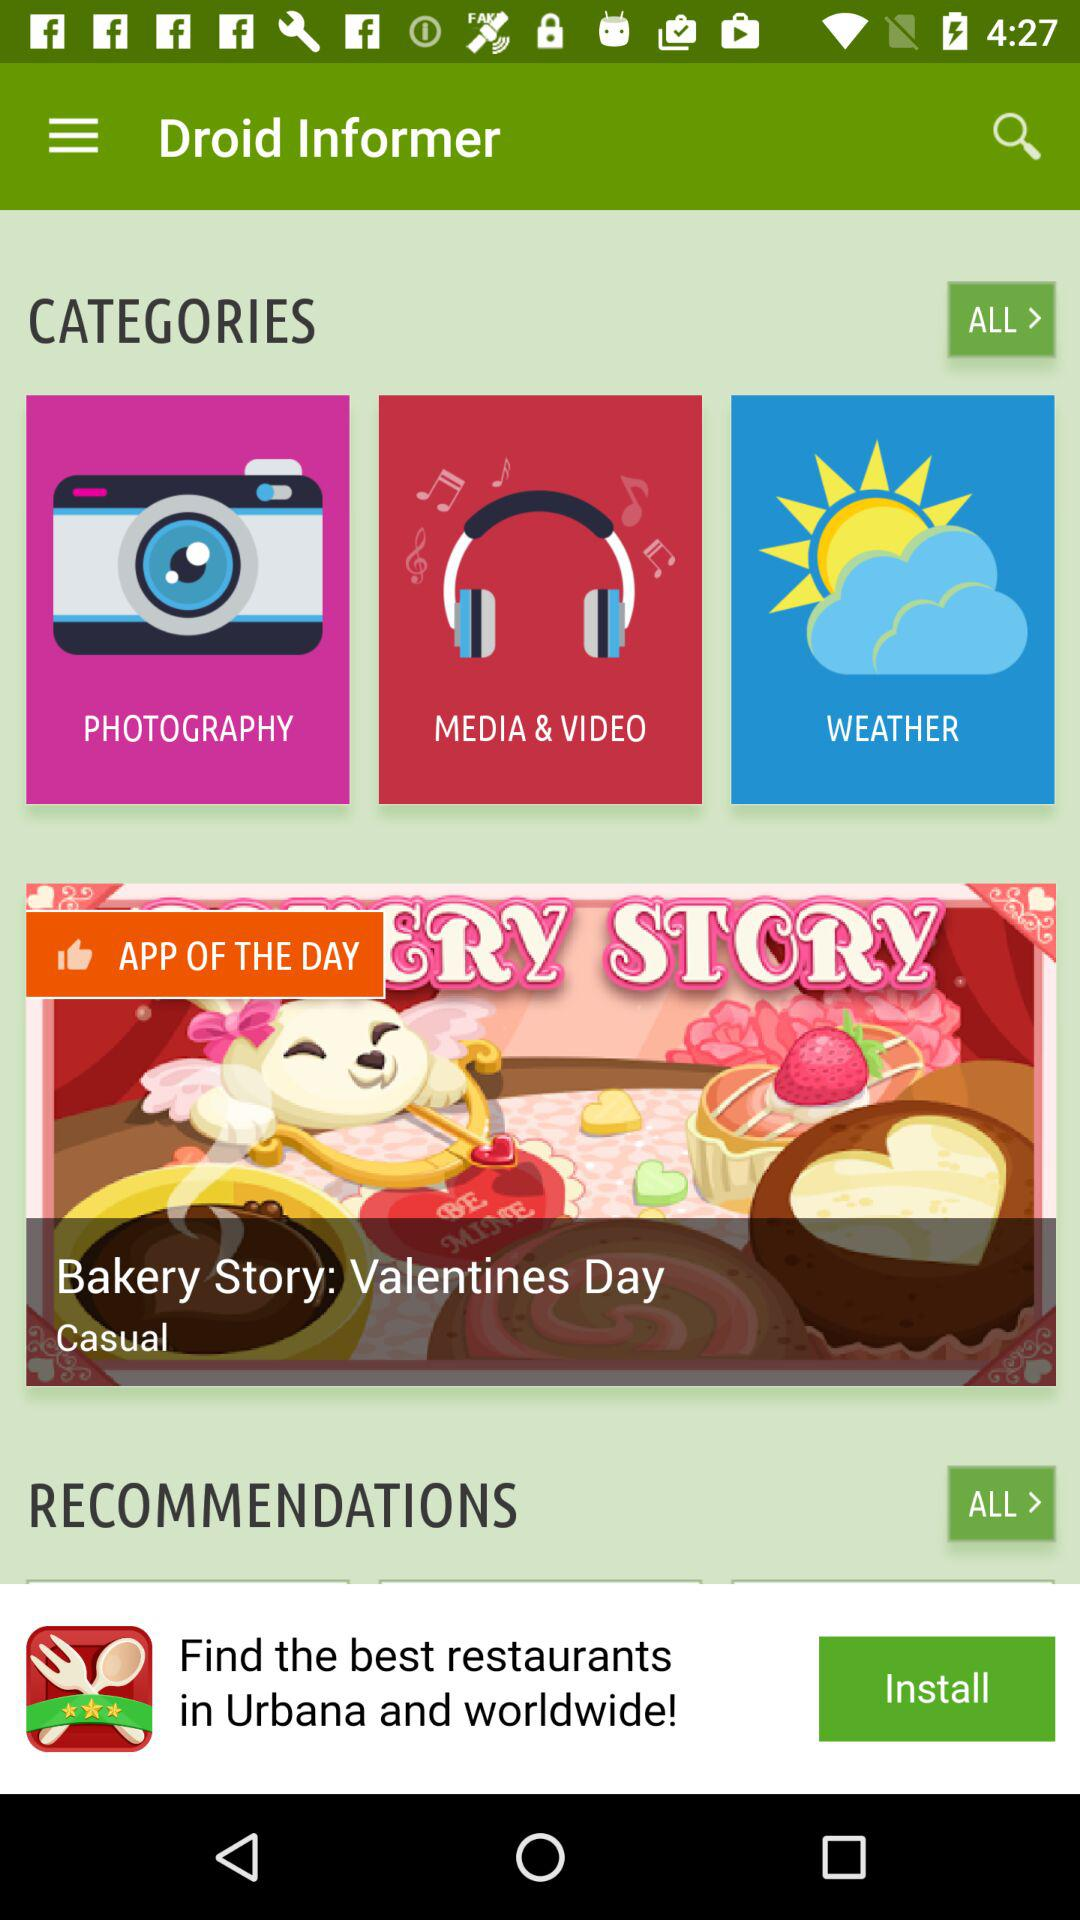What is listed in "RECOMMENDATIONS"?
When the provided information is insufficient, respond with <no answer>. <no answer> 